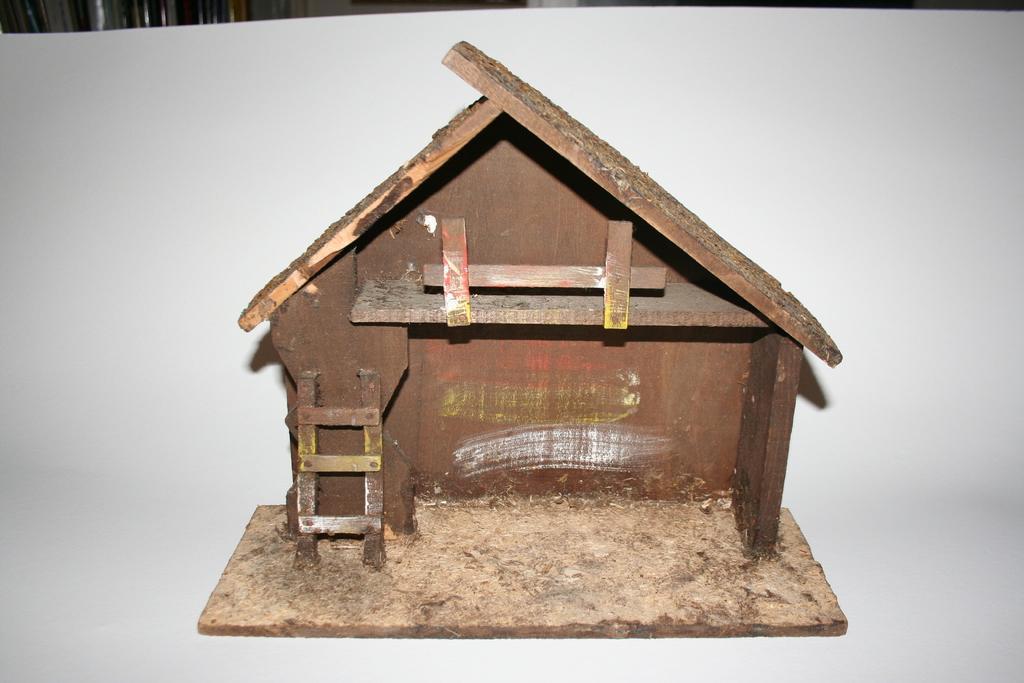In one or two sentences, can you explain what this image depicts? In this image I can see a brown colour miniature shack. I can also see white colour in background. 